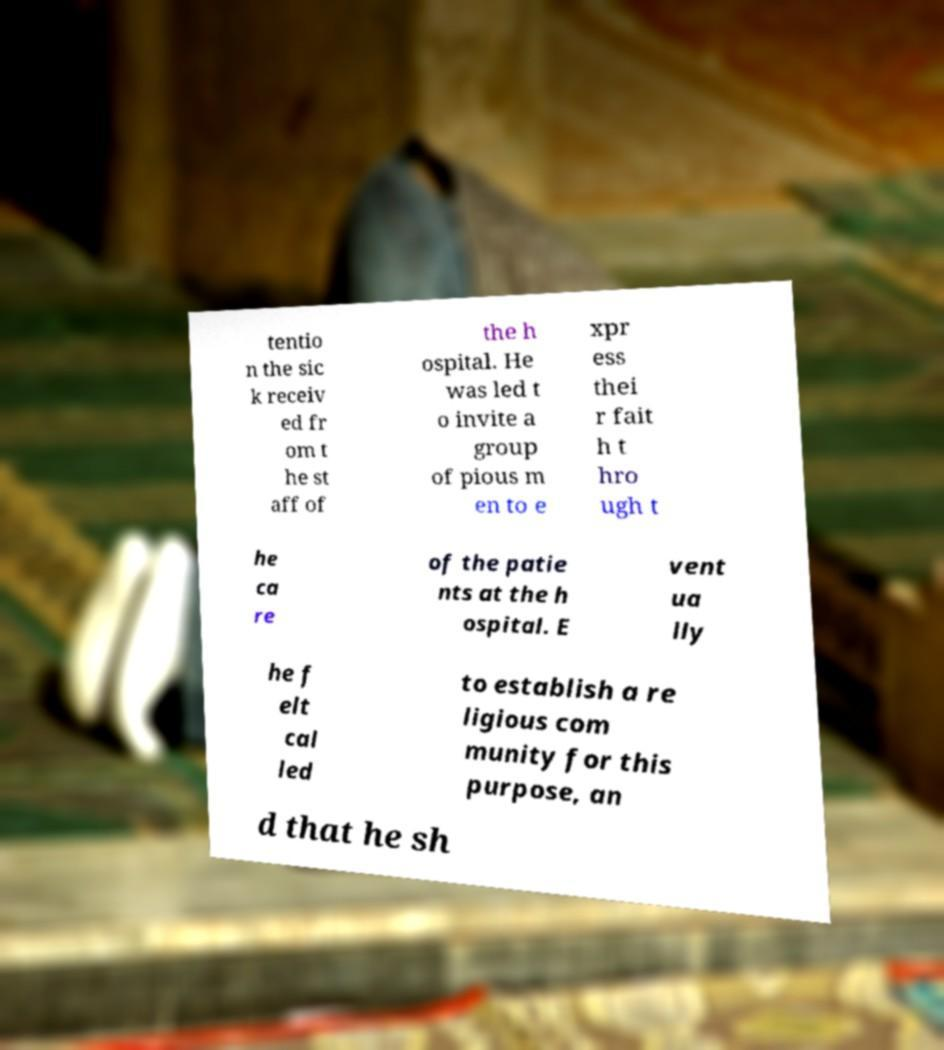Can you accurately transcribe the text from the provided image for me? tentio n the sic k receiv ed fr om t he st aff of the h ospital. He was led t o invite a group of pious m en to e xpr ess thei r fait h t hro ugh t he ca re of the patie nts at the h ospital. E vent ua lly he f elt cal led to establish a re ligious com munity for this purpose, an d that he sh 